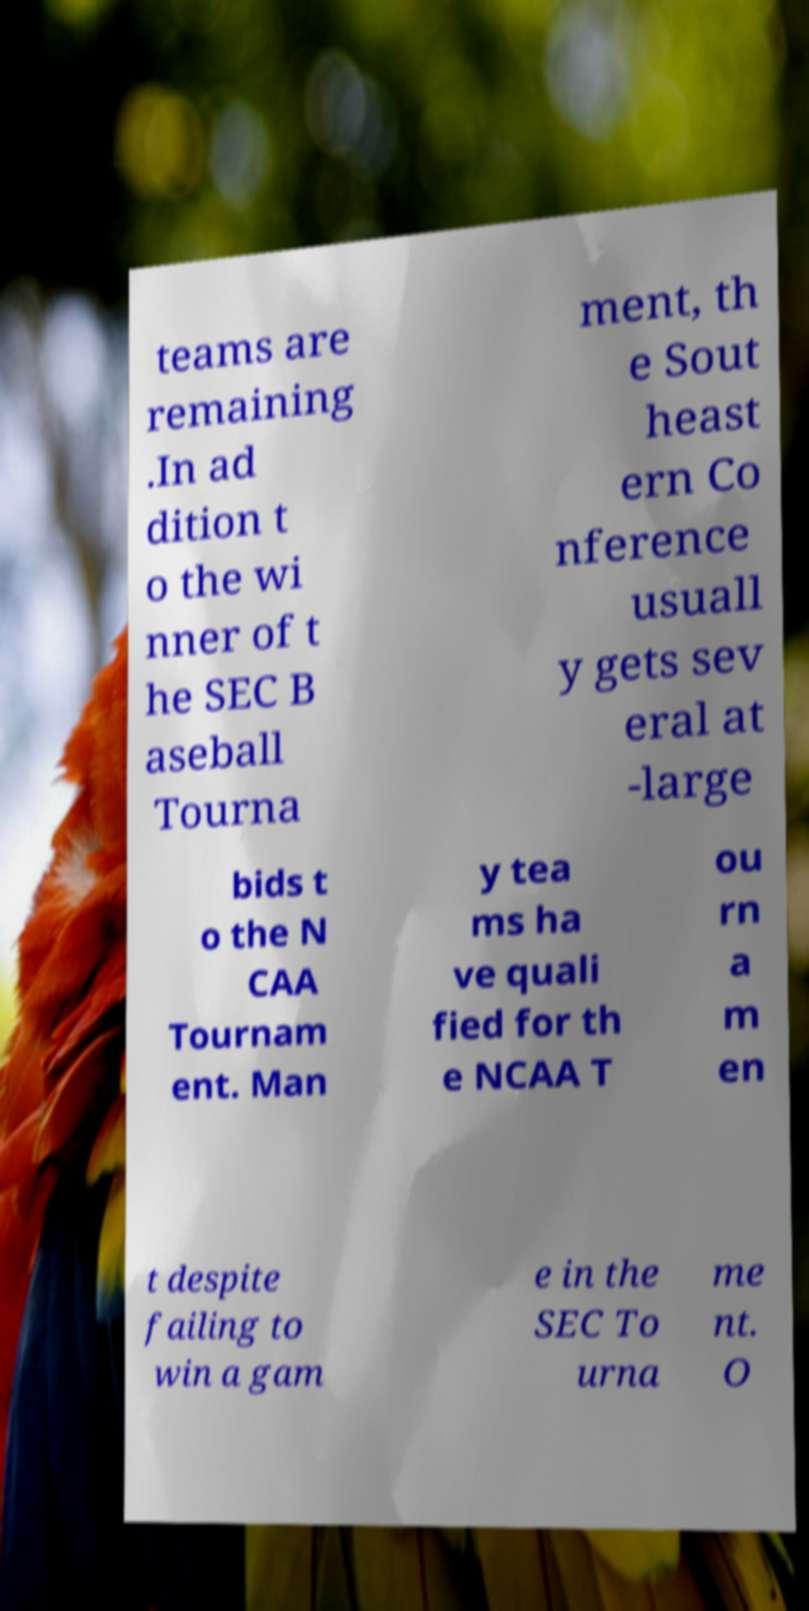What messages or text are displayed in this image? I need them in a readable, typed format. teams are remaining .In ad dition t o the wi nner of t he SEC B aseball Tourna ment, th e Sout heast ern Co nference usuall y gets sev eral at -large bids t o the N CAA Tournam ent. Man y tea ms ha ve quali fied for th e NCAA T ou rn a m en t despite failing to win a gam e in the SEC To urna me nt. O 